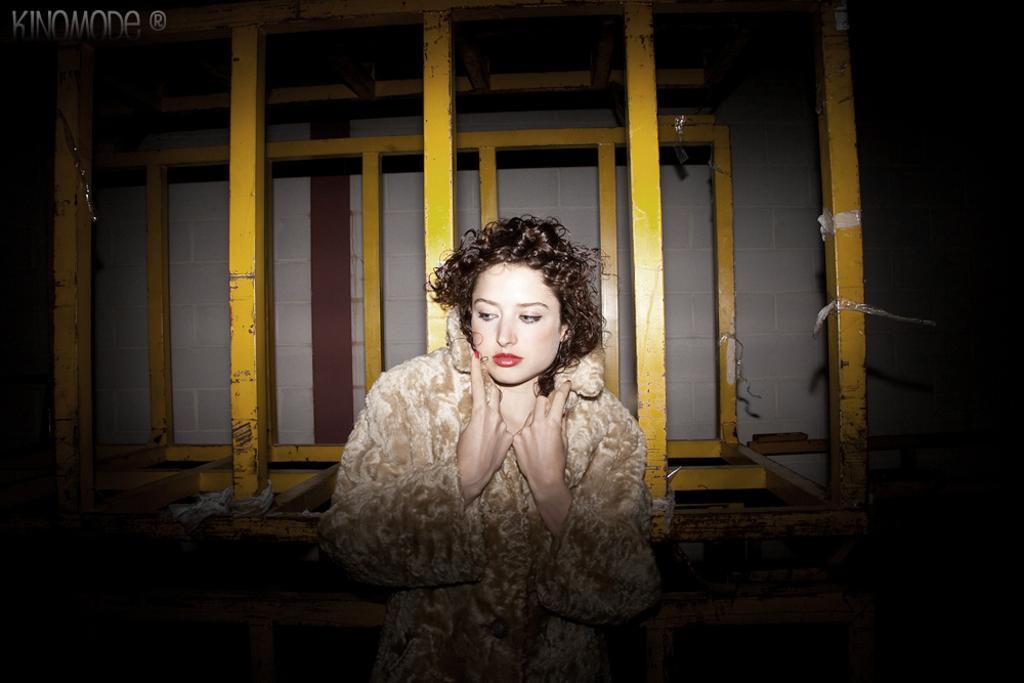Can you describe this image briefly? In this image we can see a woman. On the backside we can see some poles and a wall. 